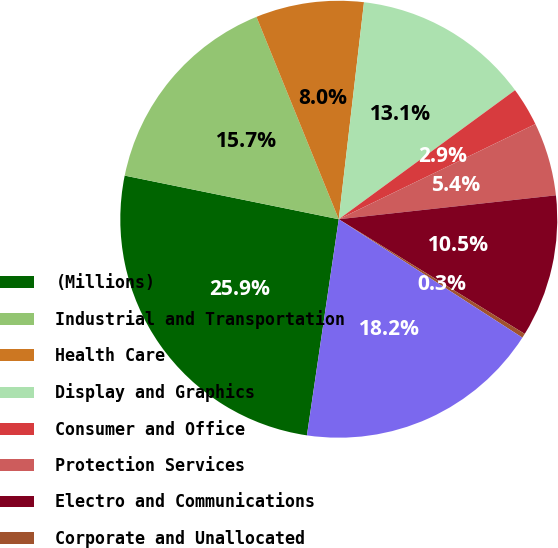<chart> <loc_0><loc_0><loc_500><loc_500><pie_chart><fcel>(Millions)<fcel>Industrial and Transportation<fcel>Health Care<fcel>Display and Graphics<fcel>Consumer and Office<fcel>Protection Services<fcel>Electro and Communications<fcel>Corporate and Unallocated<fcel>Total Company<nl><fcel>25.87%<fcel>15.65%<fcel>7.99%<fcel>13.1%<fcel>2.88%<fcel>5.43%<fcel>10.54%<fcel>0.32%<fcel>18.21%<nl></chart> 